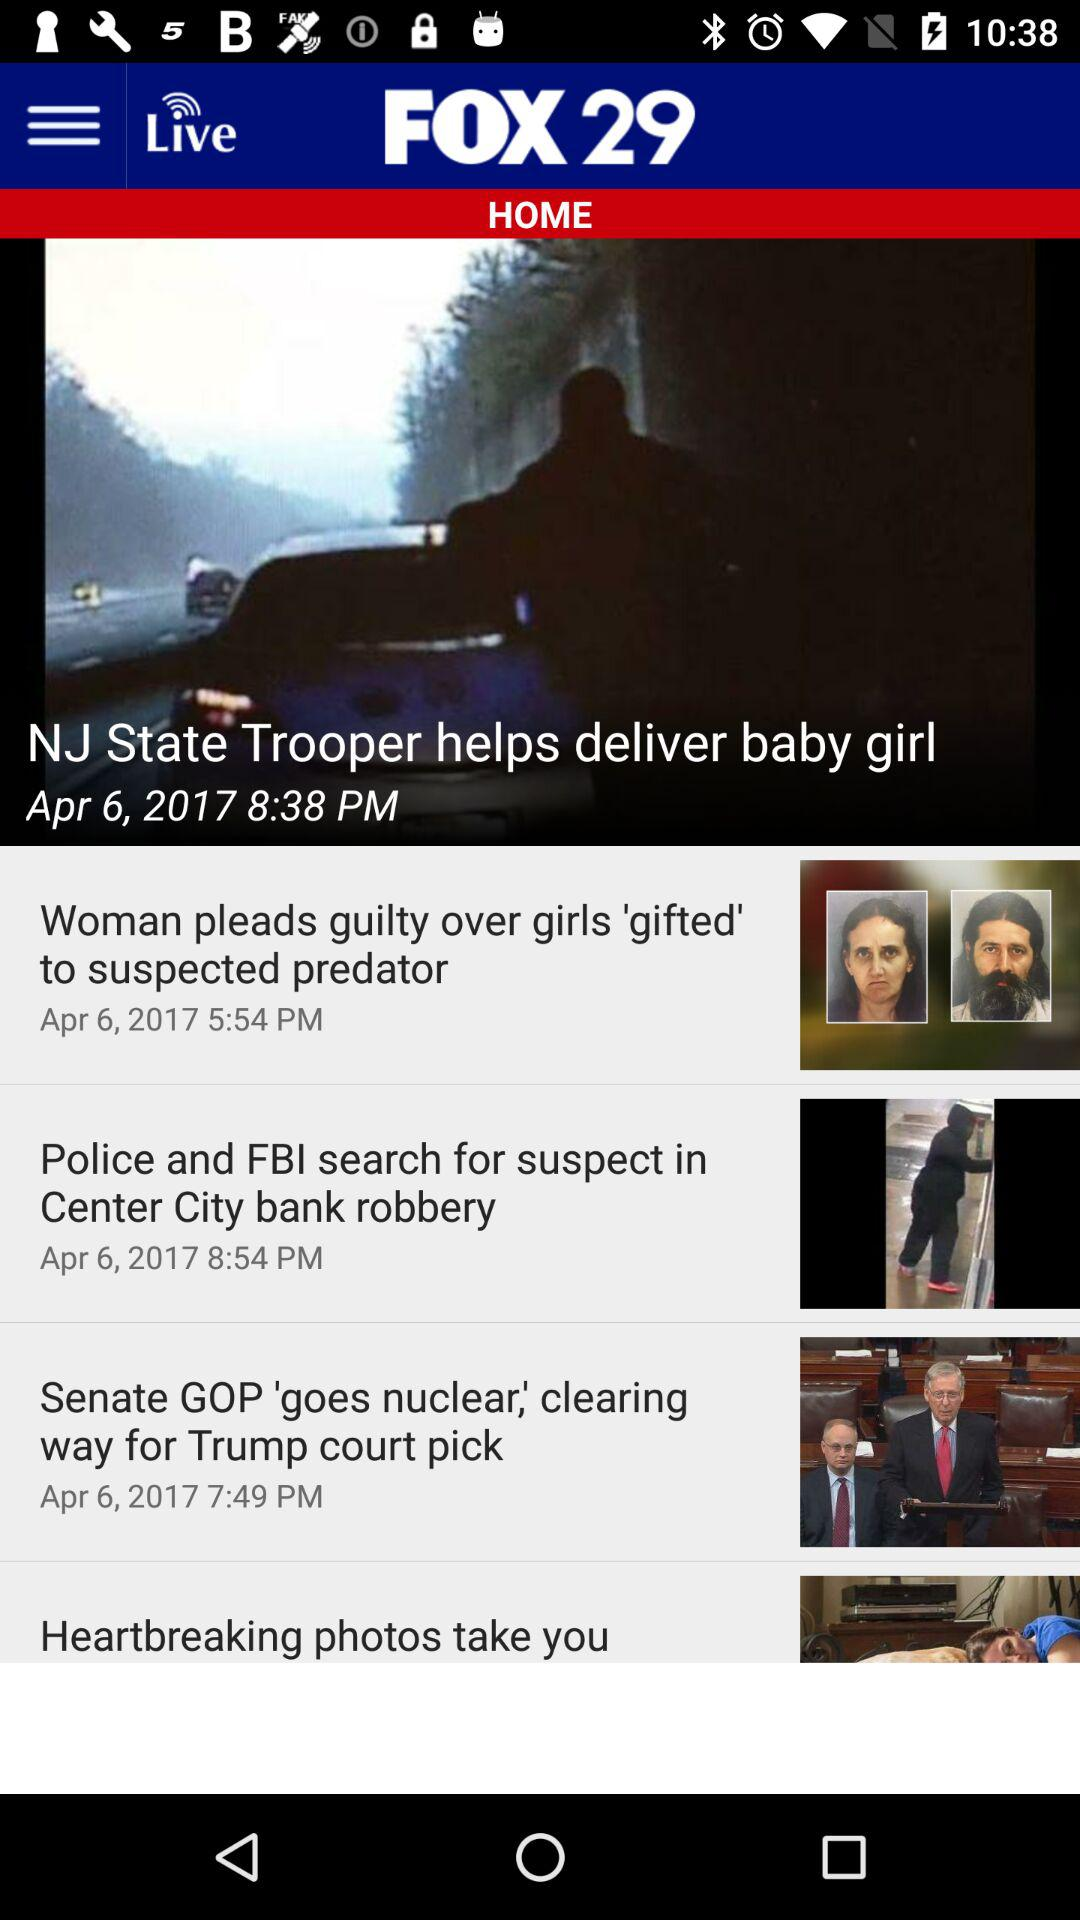What is the application name? The application name is "FOX 29". 